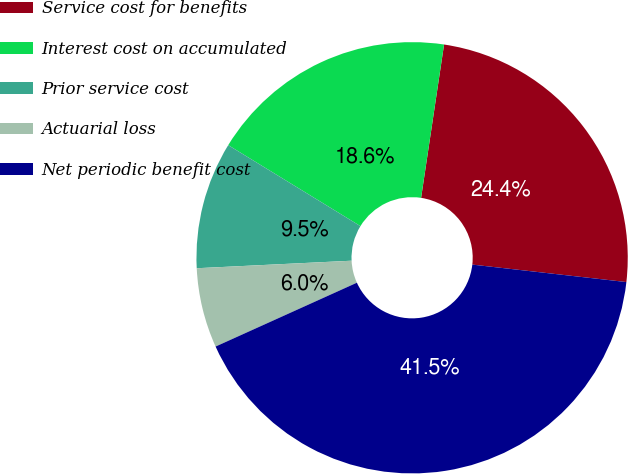Convert chart. <chart><loc_0><loc_0><loc_500><loc_500><pie_chart><fcel>Service cost for benefits<fcel>Interest cost on accumulated<fcel>Prior service cost<fcel>Actuarial loss<fcel>Net periodic benefit cost<nl><fcel>24.43%<fcel>18.62%<fcel>9.52%<fcel>5.98%<fcel>41.45%<nl></chart> 